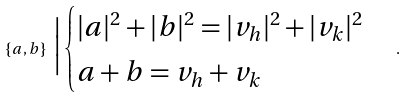Convert formula to latex. <formula><loc_0><loc_0><loc_500><loc_500>\{ a , b \} \ \Big | \begin{cases} | a | ^ { 2 } + | b | ^ { 2 } = | v _ { h } | ^ { 2 } + | v _ { k } | ^ { 2 } \\ a + b = v _ { h } + v _ { k } \end{cases} .</formula> 